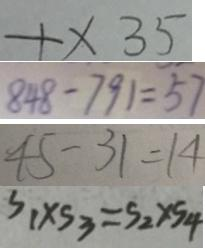Convert formula to latex. <formula><loc_0><loc_0><loc_500><loc_500>+ \times 3 5 
 8 4 8 - 7 9 1 = 5 7 
 4 5 - 3 1 = 1 4 
 S _ { 1 } \times S _ { 3 } = S _ { 2 } \times S _ { 4 }</formula> 